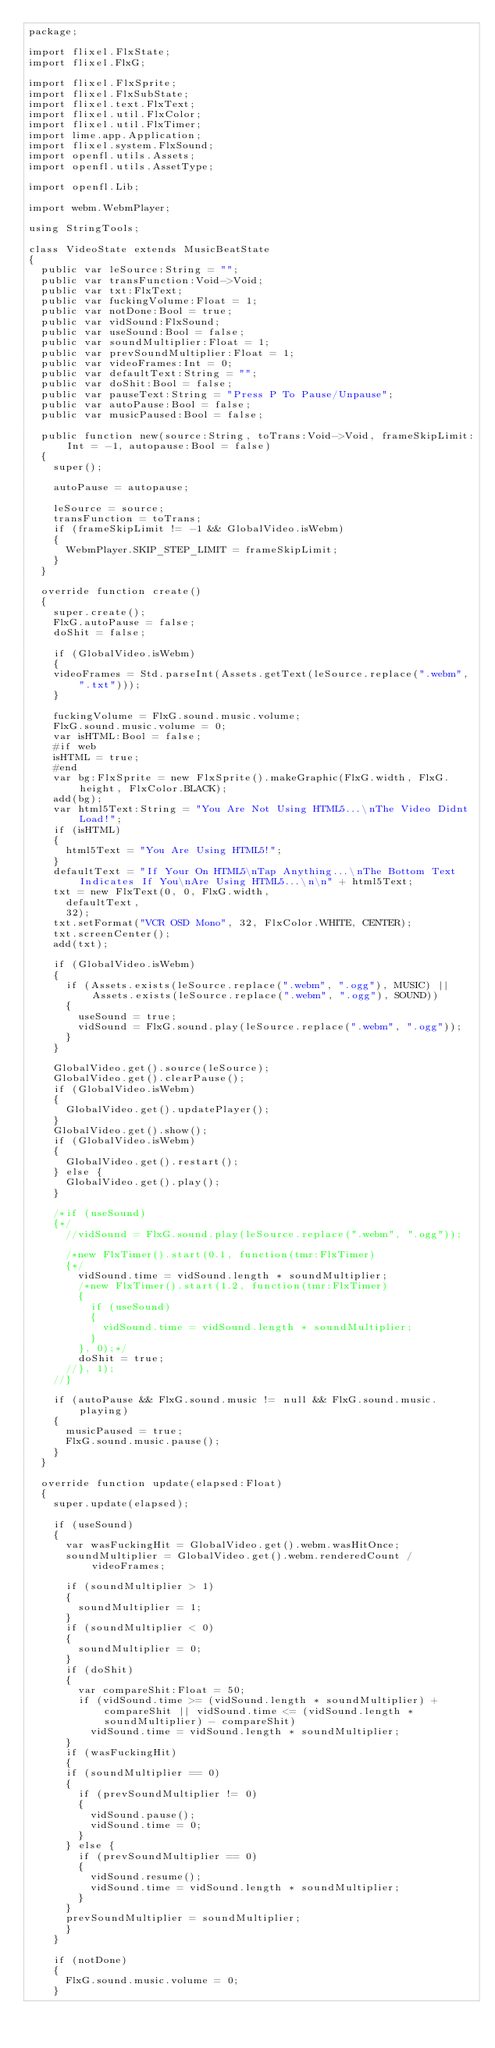<code> <loc_0><loc_0><loc_500><loc_500><_Haxe_>package;

import flixel.FlxState;
import flixel.FlxG;

import flixel.FlxSprite;
import flixel.FlxSubState;
import flixel.text.FlxText;
import flixel.util.FlxColor;
import flixel.util.FlxTimer;
import lime.app.Application;
import flixel.system.FlxSound;
import openfl.utils.Assets;
import openfl.utils.AssetType;

import openfl.Lib;

import webm.WebmPlayer;

using StringTools;

class VideoState extends MusicBeatState
{
	public var leSource:String = "";
	public var transFunction:Void->Void;
	public var txt:FlxText;
	public var fuckingVolume:Float = 1;
	public var notDone:Bool = true;
	public var vidSound:FlxSound;
	public var useSound:Bool = false;
	public var soundMultiplier:Float = 1;
	public var prevSoundMultiplier:Float = 1;
	public var videoFrames:Int = 0;
	public var defaultText:String = "";
	public var doShit:Bool = false;
	public var pauseText:String = "Press P To Pause/Unpause";
	public var autoPause:Bool = false;
	public var musicPaused:Bool = false;

	public function new(source:String, toTrans:Void->Void, frameSkipLimit:Int = -1, autopause:Bool = false)
	{
		super();
		
		autoPause = autopause;
		
		leSource = source;
		transFunction = toTrans;
		if (frameSkipLimit != -1 && GlobalVideo.isWebm)
		{
			WebmPlayer.SKIP_STEP_LIMIT = frameSkipLimit;	
		}
	}
	
	override function create()
	{
		super.create();
		FlxG.autoPause = false;
		doShit = false;
		
		if (GlobalVideo.isWebm)
		{
		videoFrames = Std.parseInt(Assets.getText(leSource.replace(".webm", ".txt")));
		}
		
		fuckingVolume = FlxG.sound.music.volume;
		FlxG.sound.music.volume = 0;
		var isHTML:Bool = false;
		#if web
		isHTML = true;
		#end
		var bg:FlxSprite = new FlxSprite().makeGraphic(FlxG.width, FlxG.height, FlxColor.BLACK);
		add(bg);
		var html5Text:String = "You Are Not Using HTML5...\nThe Video Didnt Load!";
		if (isHTML)
		{
			html5Text = "You Are Using HTML5!";
		}
		defaultText = "If Your On HTML5\nTap Anything...\nThe Bottom Text Indicates If You\nAre Using HTML5...\n\n" + html5Text;
		txt = new FlxText(0, 0, FlxG.width,
			defaultText,
			32);
		txt.setFormat("VCR OSD Mono", 32, FlxColor.WHITE, CENTER);
		txt.screenCenter();
		add(txt);

		if (GlobalVideo.isWebm)
		{
			if (Assets.exists(leSource.replace(".webm", ".ogg"), MUSIC) || Assets.exists(leSource.replace(".webm", ".ogg"), SOUND))
			{
				useSound = true;
				vidSound = FlxG.sound.play(leSource.replace(".webm", ".ogg"));
			}
		}

		GlobalVideo.get().source(leSource);
		GlobalVideo.get().clearPause();
		if (GlobalVideo.isWebm)
		{
			GlobalVideo.get().updatePlayer();
		}
		GlobalVideo.get().show();
		if (GlobalVideo.isWebm)
		{
			GlobalVideo.get().restart();
		} else {
			GlobalVideo.get().play();
		}
		
		/*if (useSound)
		{*/
			//vidSound = FlxG.sound.play(leSource.replace(".webm", ".ogg"));
		
			/*new FlxTimer().start(0.1, function(tmr:FlxTimer)
			{*/
				vidSound.time = vidSound.length * soundMultiplier;
				/*new FlxTimer().start(1.2, function(tmr:FlxTimer)
				{
					if (useSound)
					{
						vidSound.time = vidSound.length * soundMultiplier;
					}
				}, 0);*/
				doShit = true;
			//}, 1);
		//}
		
		if (autoPause && FlxG.sound.music != null && FlxG.sound.music.playing)
		{
			musicPaused = true;
			FlxG.sound.music.pause();
		}
	}
	
	override function update(elapsed:Float)
	{
		super.update(elapsed);
		
		if (useSound)
		{
			var wasFuckingHit = GlobalVideo.get().webm.wasHitOnce;
			soundMultiplier = GlobalVideo.get().webm.renderedCount / videoFrames;
			
			if (soundMultiplier > 1)
			{
				soundMultiplier = 1;
			}
			if (soundMultiplier < 0)
			{
				soundMultiplier = 0;
			}
			if (doShit)
			{
				var compareShit:Float = 50;
				if (vidSound.time >= (vidSound.length * soundMultiplier) + compareShit || vidSound.time <= (vidSound.length * soundMultiplier) - compareShit)
					vidSound.time = vidSound.length * soundMultiplier;
			}
			if (wasFuckingHit)
			{
			if (soundMultiplier == 0)
			{
				if (prevSoundMultiplier != 0)
				{
					vidSound.pause();
					vidSound.time = 0;
				}
			} else {
				if (prevSoundMultiplier == 0)
				{
					vidSound.resume();
					vidSound.time = vidSound.length * soundMultiplier;
				}
			}
			prevSoundMultiplier = soundMultiplier;
			}
		}
		
		if (notDone)
		{
			FlxG.sound.music.volume = 0;
		}</code> 